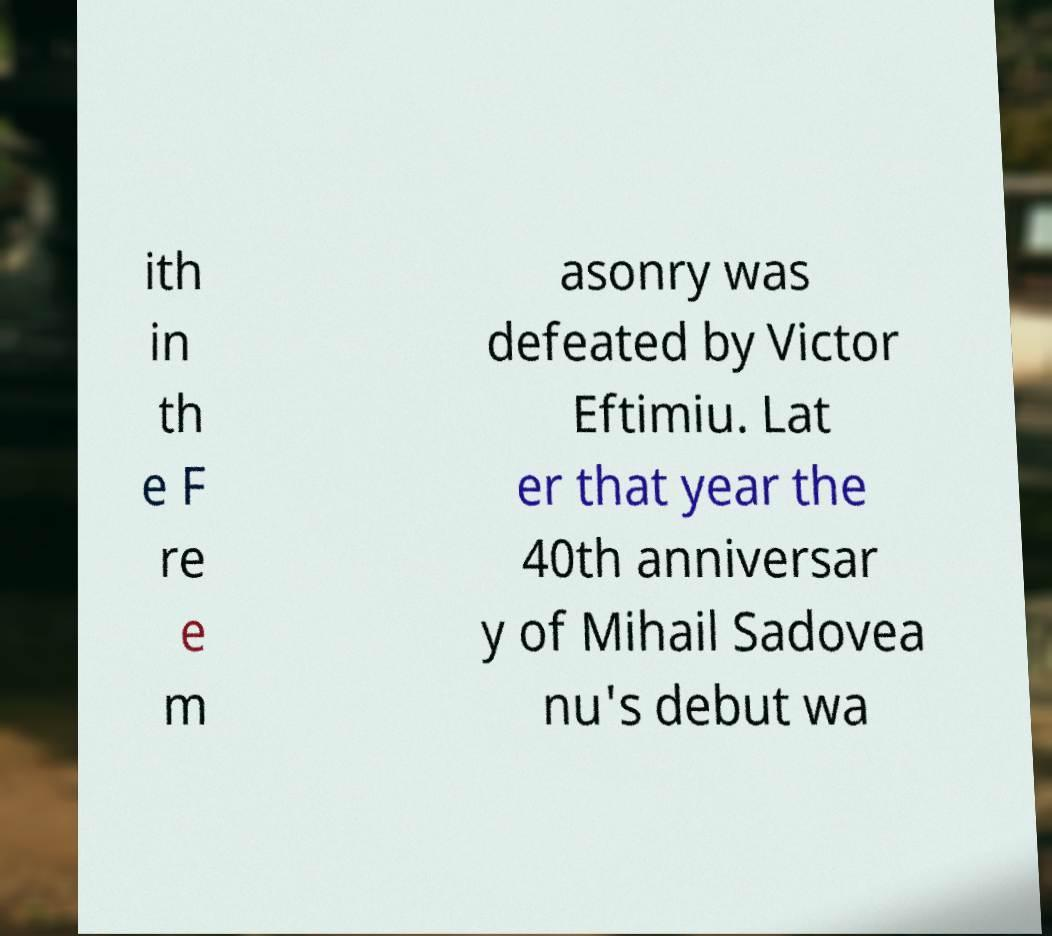For documentation purposes, I need the text within this image transcribed. Could you provide that? ith in th e F re e m asonry was defeated by Victor Eftimiu. Lat er that year the 40th anniversar y of Mihail Sadovea nu's debut wa 